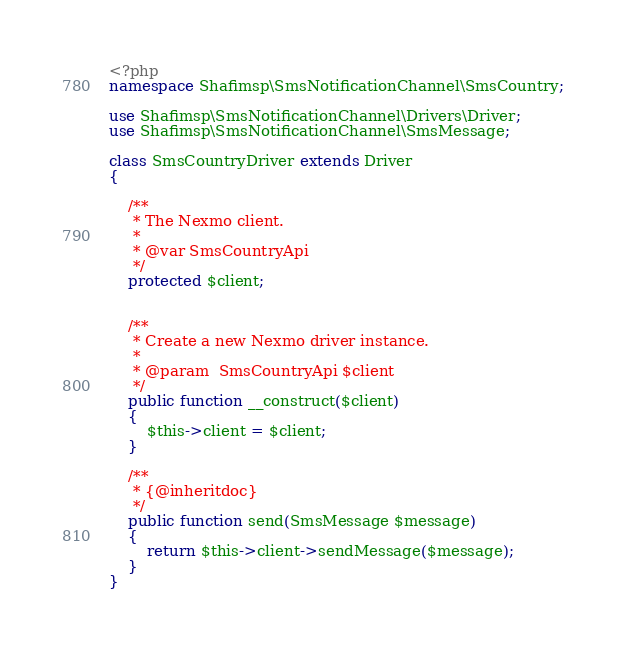<code> <loc_0><loc_0><loc_500><loc_500><_PHP_><?php
namespace Shafimsp\SmsNotificationChannel\SmsCountry;

use Shafimsp\SmsNotificationChannel\Drivers\Driver;
use Shafimsp\SmsNotificationChannel\SmsMessage;

class SmsCountryDriver extends Driver
{

    /**
     * The Nexmo client.
     *
     * @var SmsCountryApi
     */
    protected $client;


    /**
     * Create a new Nexmo driver instance.
     *
     * @param  SmsCountryApi $client
     */
    public function __construct($client)
    {
        $this->client = $client;
    }

    /**
     * {@inheritdoc}
     */
    public function send(SmsMessage $message)
    {
        return $this->client->sendMessage($message);
    }
}</code> 